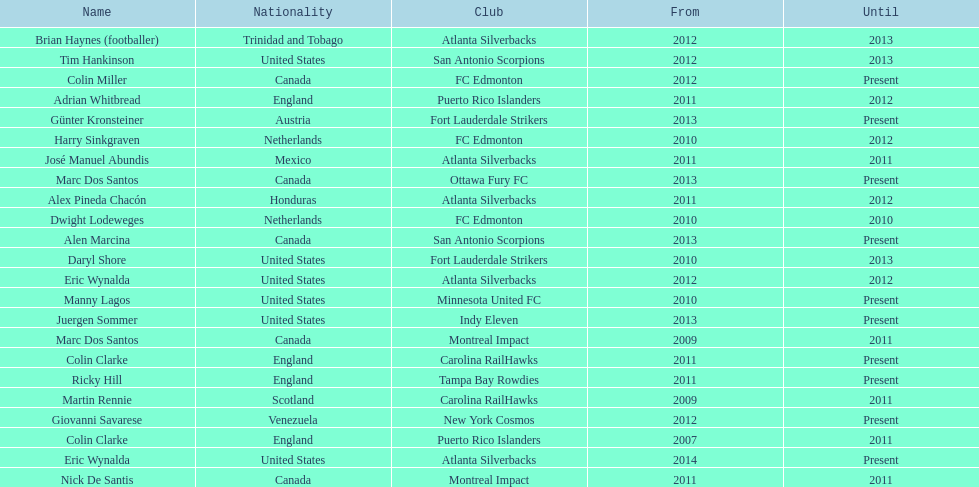How long did colin clarke coach the puerto rico islanders for? 4 years. Could you help me parse every detail presented in this table? {'header': ['Name', 'Nationality', 'Club', 'From', 'Until'], 'rows': [['Brian Haynes (footballer)', 'Trinidad and Tobago', 'Atlanta Silverbacks', '2012', '2013'], ['Tim Hankinson', 'United States', 'San Antonio Scorpions', '2012', '2013'], ['Colin Miller', 'Canada', 'FC Edmonton', '2012', 'Present'], ['Adrian Whitbread', 'England', 'Puerto Rico Islanders', '2011', '2012'], ['Günter Kronsteiner', 'Austria', 'Fort Lauderdale Strikers', '2013', 'Present'], ['Harry Sinkgraven', 'Netherlands', 'FC Edmonton', '2010', '2012'], ['José Manuel Abundis', 'Mexico', 'Atlanta Silverbacks', '2011', '2011'], ['Marc Dos Santos', 'Canada', 'Ottawa Fury FC', '2013', 'Present'], ['Alex Pineda Chacón', 'Honduras', 'Atlanta Silverbacks', '2011', '2012'], ['Dwight Lodeweges', 'Netherlands', 'FC Edmonton', '2010', '2010'], ['Alen Marcina', 'Canada', 'San Antonio Scorpions', '2013', 'Present'], ['Daryl Shore', 'United States', 'Fort Lauderdale Strikers', '2010', '2013'], ['Eric Wynalda', 'United States', 'Atlanta Silverbacks', '2012', '2012'], ['Manny Lagos', 'United States', 'Minnesota United FC', '2010', 'Present'], ['Juergen Sommer', 'United States', 'Indy Eleven', '2013', 'Present'], ['Marc Dos Santos', 'Canada', 'Montreal Impact', '2009', '2011'], ['Colin Clarke', 'England', 'Carolina RailHawks', '2011', 'Present'], ['Ricky Hill', 'England', 'Tampa Bay Rowdies', '2011', 'Present'], ['Martin Rennie', 'Scotland', 'Carolina RailHawks', '2009', '2011'], ['Giovanni Savarese', 'Venezuela', 'New York Cosmos', '2012', 'Present'], ['Colin Clarke', 'England', 'Puerto Rico Islanders', '2007', '2011'], ['Eric Wynalda', 'United States', 'Atlanta Silverbacks', '2014', 'Present'], ['Nick De Santis', 'Canada', 'Montreal Impact', '2011', '2011']]} 